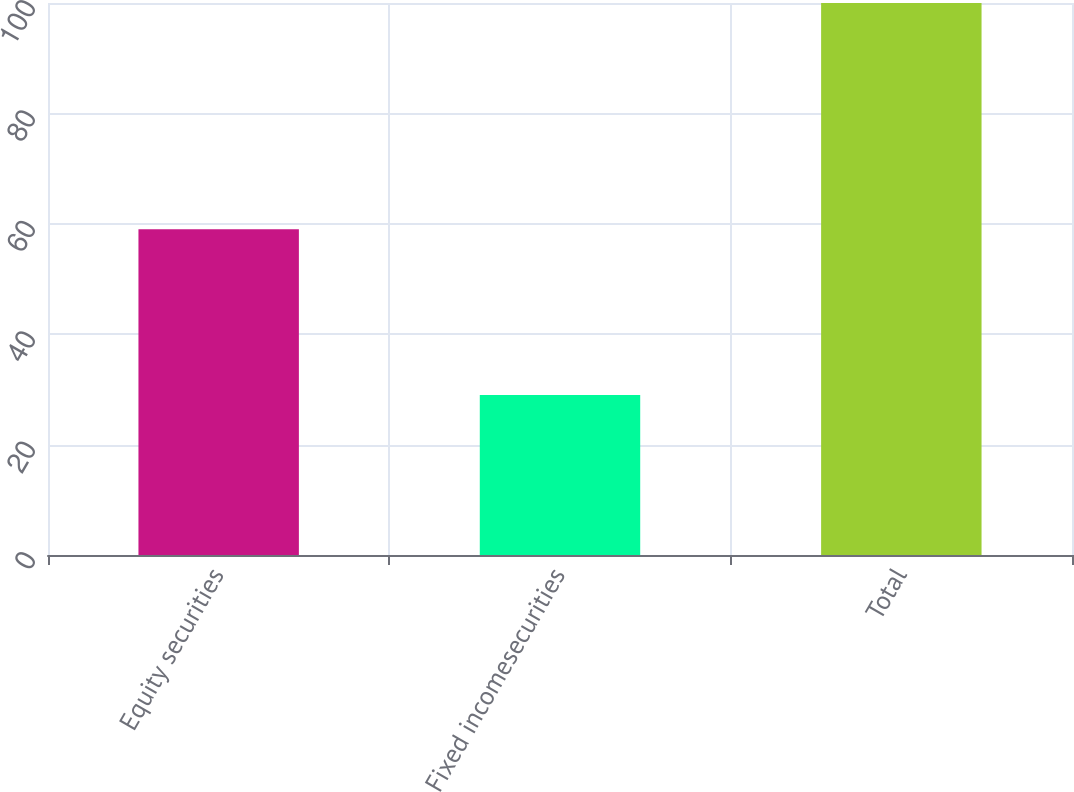Convert chart to OTSL. <chart><loc_0><loc_0><loc_500><loc_500><bar_chart><fcel>Equity securities<fcel>Fixed incomesecurities<fcel>Total<nl><fcel>59<fcel>29<fcel>100<nl></chart> 